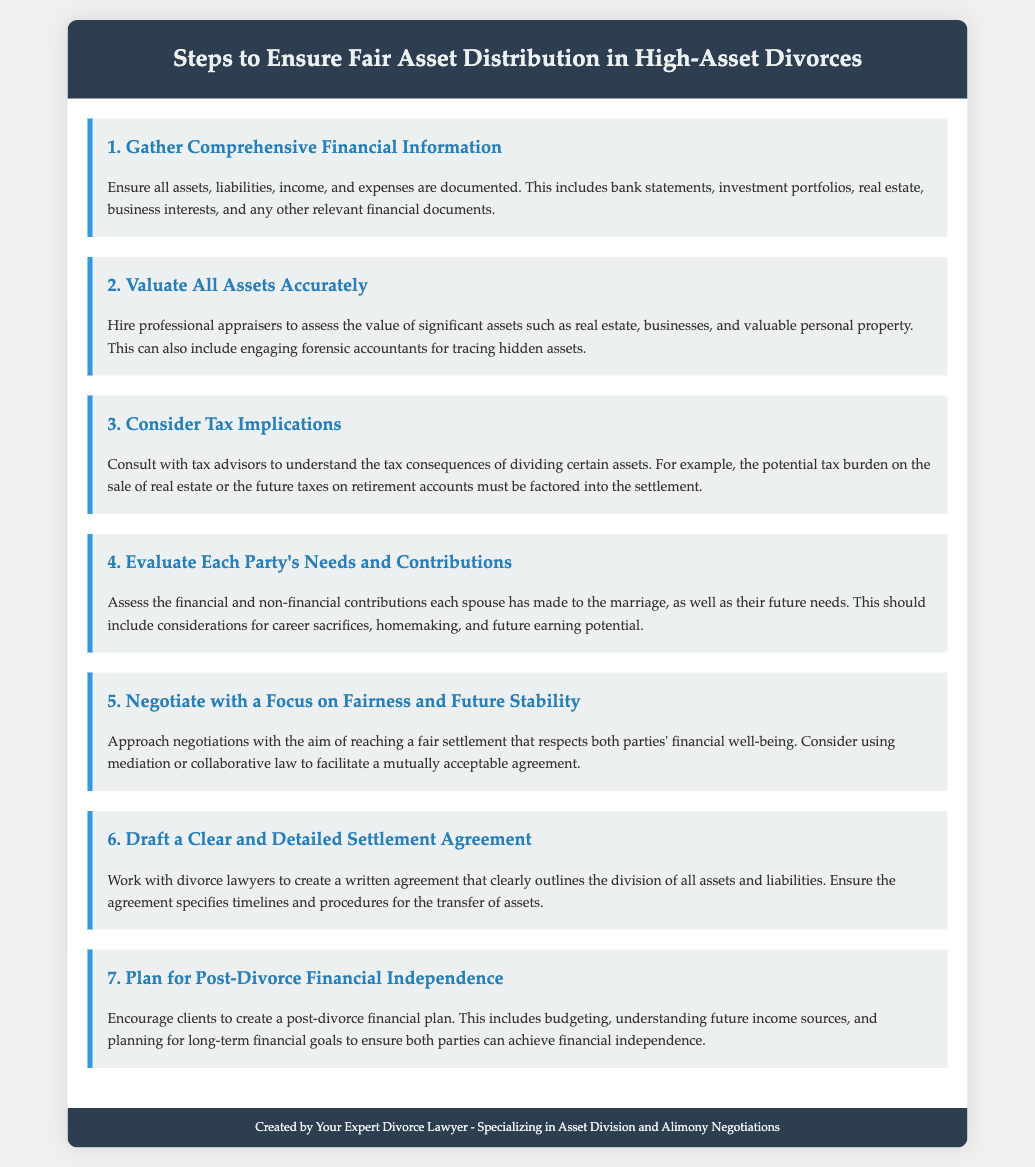What is the first step to ensure fair asset distribution? The first step listed in the document is to gather comprehensive financial information, which involves documenting all assets, liabilities, income, and expenses.
Answer: Gather Comprehensive Financial Information How many steps are there in total? The document outlines a total of seven steps for ensuring fair asset distribution in high-asset divorces.
Answer: Seven What should be considered during asset valuation? The document advises hiring professional appraisers to assess the value of significant assets and engaging forensic accountants for tracing hidden assets.
Answer: Engaging forensic accountants What does the document suggest about tax implications? It suggests consulting with tax advisors to understand the tax consequences of dividing certain assets.
Answer: Consult with tax advisors What is the purpose of the settlement agreement? The purpose is to clearly outline the division of all assets and liabilities between the parties involved.
Answer: Clearly outline the division Which type of professionals can be involved in negotiations? The document mentions that divorce lawyers can be involved in drafting the settlement agreement.
Answer: Divorce lawyers What is a key component mentioned for post-divorce planning? Encouraging clients to create a post-divorce financial plan is emphasized as a key component.
Answer: Post-divorce financial plan Which step involves assessing each party's future needs? The fourth step is focused on evaluating each party's needs and contributions to the marriage, including future needs.
Answer: Evaluate Each Party's Needs and Contributions What is the last step in the list? The last step is planning for post-divorce financial independence, which includes budgeting and understanding future income sources.
Answer: Plan for Post-Divorce Financial Independence 